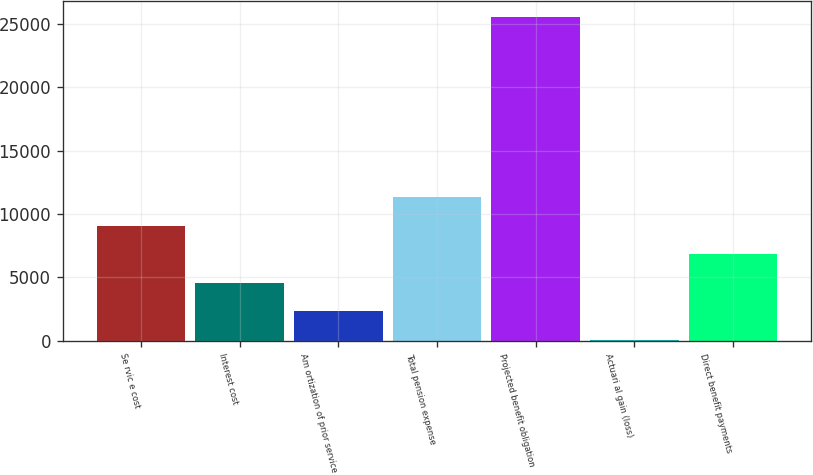Convert chart to OTSL. <chart><loc_0><loc_0><loc_500><loc_500><bar_chart><fcel>Se rvic e cost<fcel>Interest cost<fcel>Am ortization of prior service<fcel>Total pension expense<fcel>Projected benefit obligation<fcel>Actuari al gain (loss)<fcel>Direct benefit payments<nl><fcel>9081<fcel>4573<fcel>2319<fcel>11335<fcel>25586<fcel>65<fcel>6827<nl></chart> 